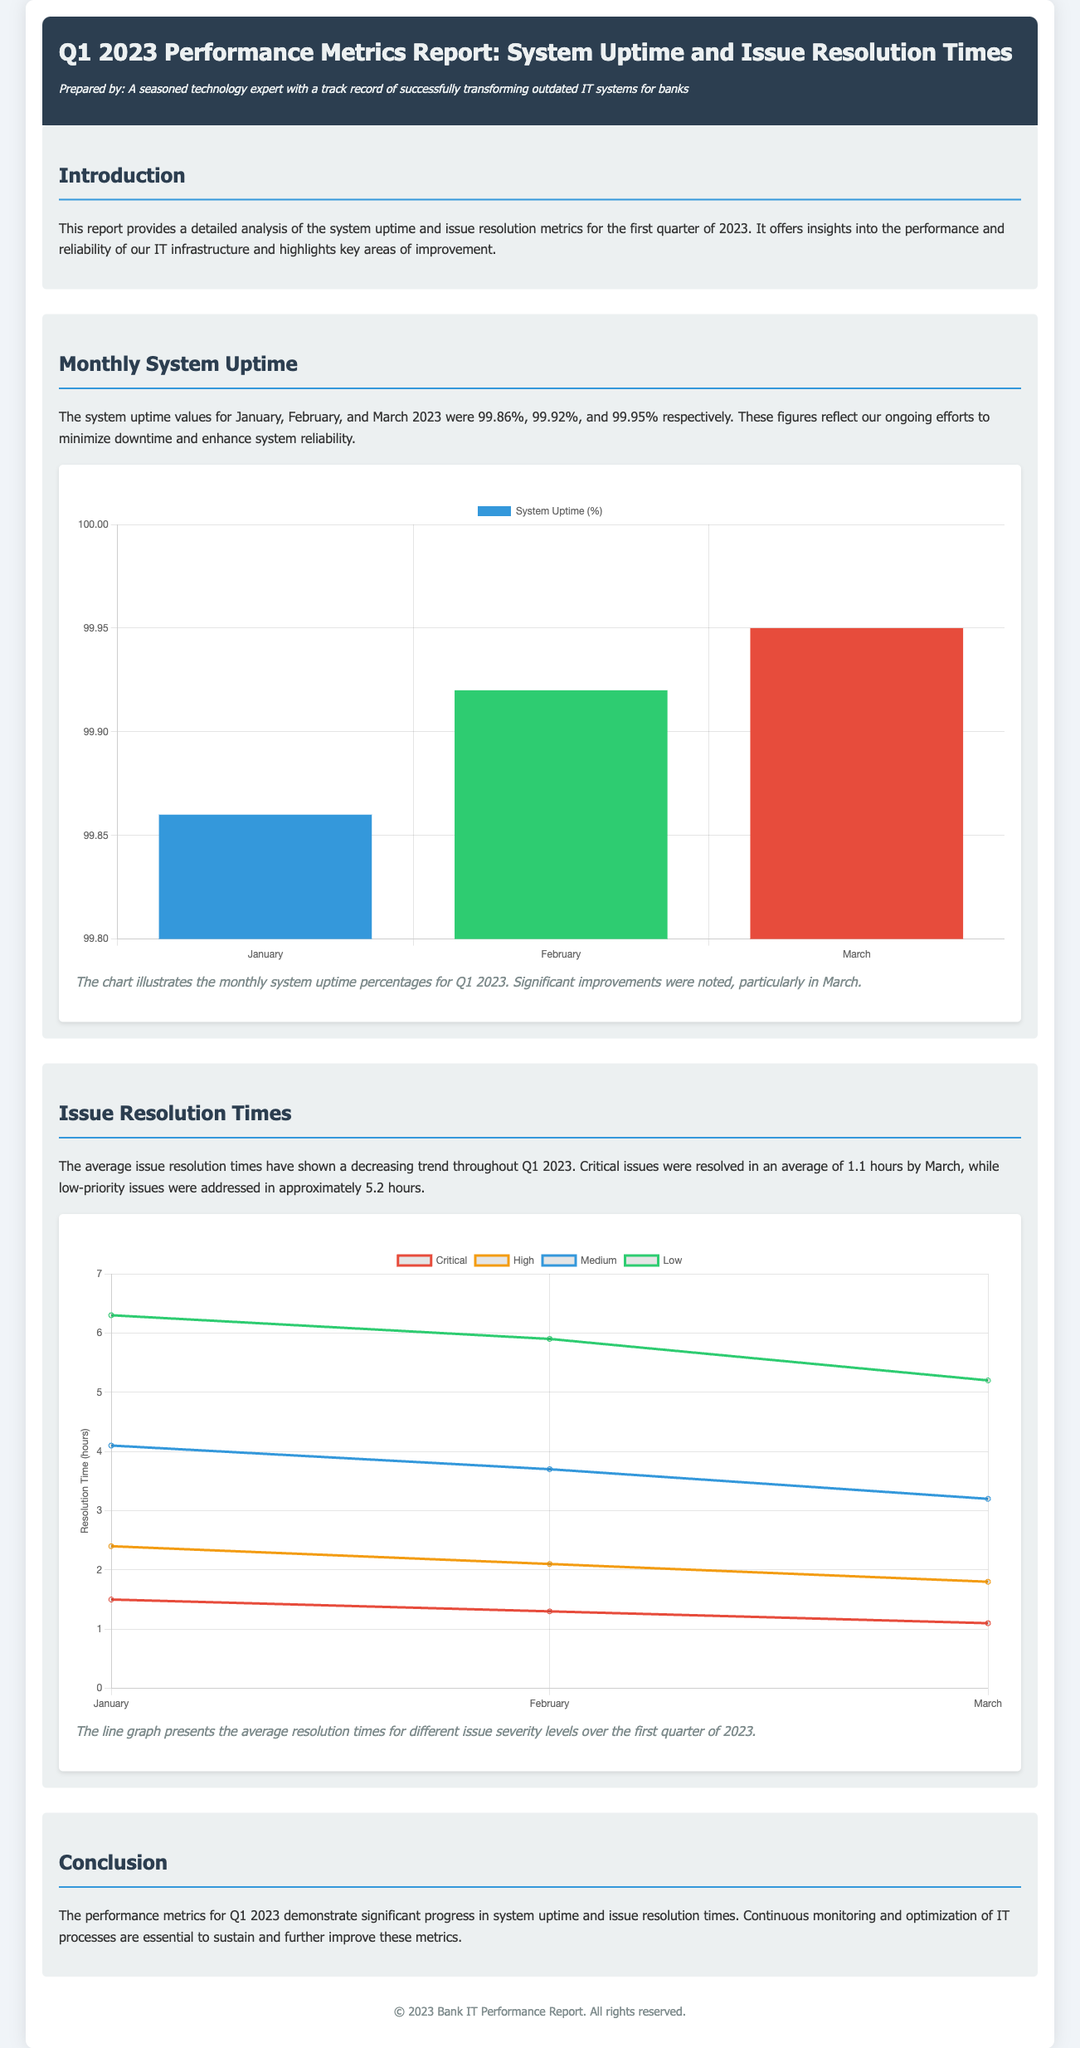What were the system uptime percentages for January, February, and March 2023? The document states the system uptime percentages for January, February, and March as 99.86%, 99.92%, and 99.95% respectively.
Answer: 99.86%, 99.92%, 99.95% What is the average resolution time for critical issues by March? The average resolution time for critical issues by March is explicitly mentioned in the document.
Answer: 1.1 hours What was the issue resolution time for low-priority issues in March? The document reports that low-priority issues were addressed in approximately 5.2 hours by March.
Answer: 5.2 hours Which month saw the highest system uptime? The report indicates that March had the highest system uptime among the three months listed.
Answer: March What type of chart is used to display the monthly system uptime? The document specifies that a bar chart illustrates the monthly system uptime percentages for Q1 2023.
Answer: Bar chart What trend is shown in the average issue resolution times throughout Q1 2023? The report indicates that the average issue resolution times displayed a decreasing trend over the quarter.
Answer: Decreasing trend What does the explanation for the uptime chart mention? The explanation for the uptime chart highlights significant improvements noted particularly in March.
Answer: Significant improvements in March What is the title of the report? The title of the report is explicitly stated at the beginning of the document.
Answer: Q1 2023 Performance Metrics Report: System Uptime and Issue Resolution Times 